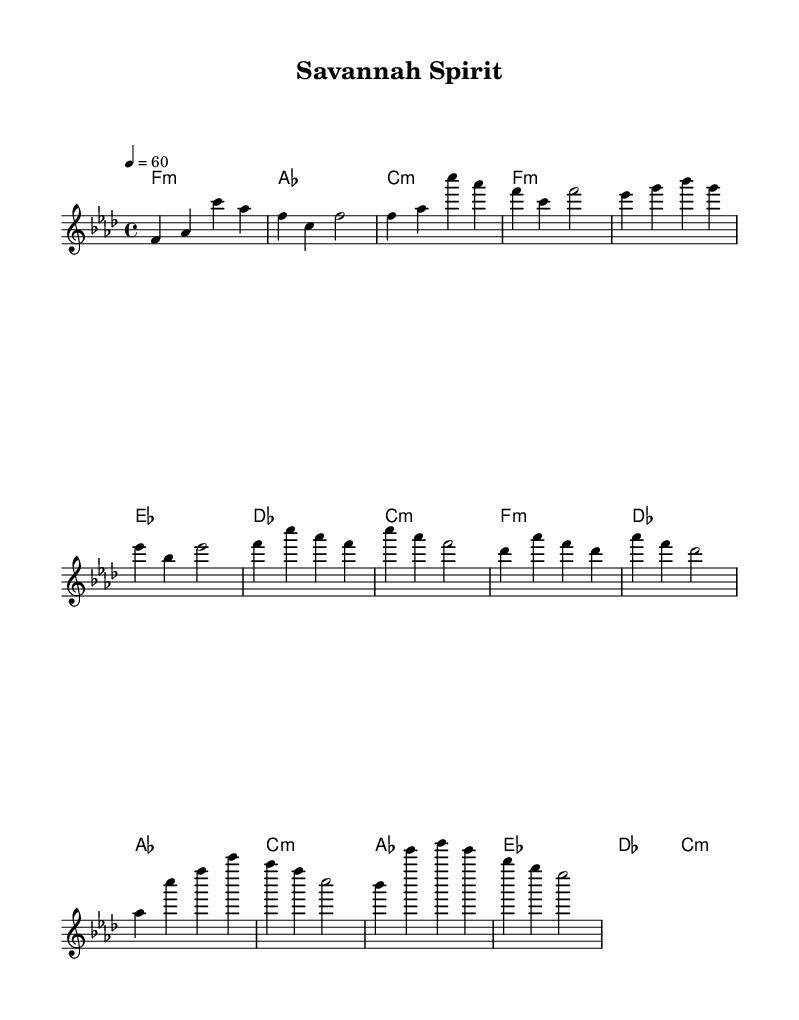What is the key signature of this music? The key signature is based on the symbol immediately following the clef at the beginning of the piece. In this case, there are four flats indicated, which corresponds to the key of F minor.
Answer: F minor What is the time signature of this music? The time signature is shown at the beginning of the staff after the key signature. Here, it displays 4/4, indicating there are four beats per measure and the quarter note gets one beat.
Answer: 4/4 What is the tempo marking of this music? The tempo marking is found at the top of the score, dictating the speed of the music. The marking states "4 = 60," meaning that there are 60 beats per minute with quarter notes.
Answer: 60 How many sections does the piece consist of? By analyzing the structure of the music, we can determine that there are four main sections indicated: Intro, Verse, Chorus, and Bridge.
Answer: Four What type of musical scale is predominantly used in this piece? The predominant use of chords and melodies reflects the characteristics of the F minor scale throughout the piece. This is evident in the melody and harmony sections primarily using notes from this scale.
Answer: F minor scale What is the primary mood conveyed in this ballad? The overall mood can be inferred from the style and the nature of each section, with soulful melodies often evoking feelings of nostalgia and emotion, reflective of the African savannah's beauty.
Answer: Soulful 